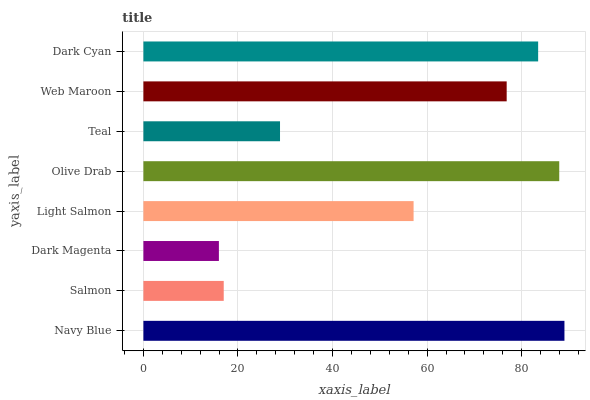Is Dark Magenta the minimum?
Answer yes or no. Yes. Is Navy Blue the maximum?
Answer yes or no. Yes. Is Salmon the minimum?
Answer yes or no. No. Is Salmon the maximum?
Answer yes or no. No. Is Navy Blue greater than Salmon?
Answer yes or no. Yes. Is Salmon less than Navy Blue?
Answer yes or no. Yes. Is Salmon greater than Navy Blue?
Answer yes or no. No. Is Navy Blue less than Salmon?
Answer yes or no. No. Is Web Maroon the high median?
Answer yes or no. Yes. Is Light Salmon the low median?
Answer yes or no. Yes. Is Olive Drab the high median?
Answer yes or no. No. Is Teal the low median?
Answer yes or no. No. 